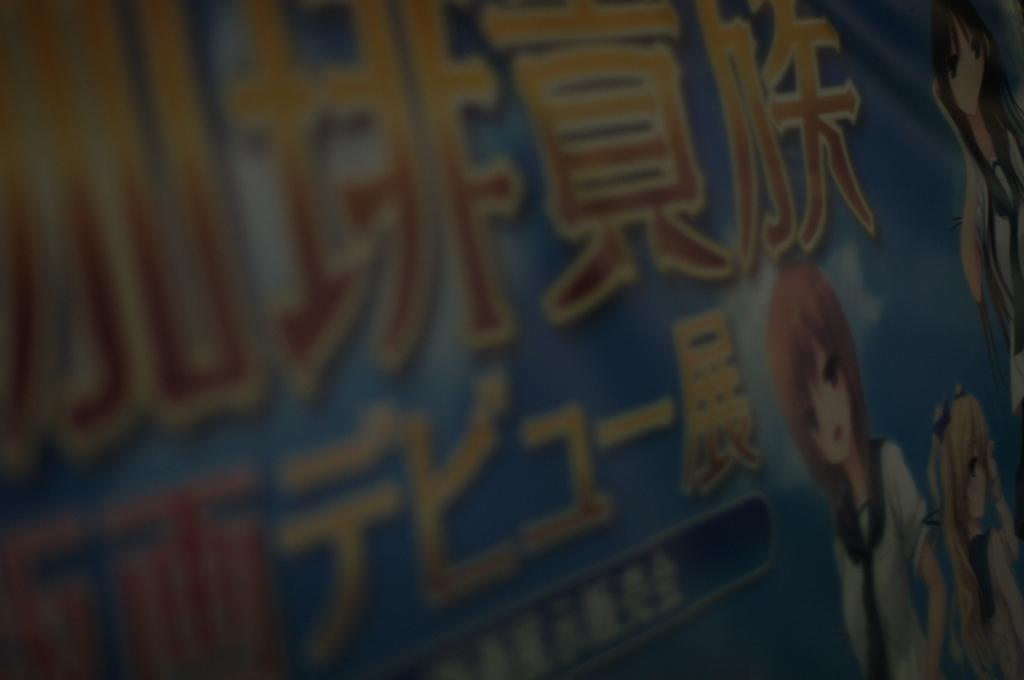What type of poster is featured in the image? There is an animation poster in the image. What is depicted on the poster? Girls are standing on the poster. Where is the map located on the poster? There is no map present on the poster; it features girls standing on it. What type of lock is used to secure the base of the poster? There is no lock or base mentioned in the image; it only features an animation poster with girls standing on it. 